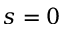<formula> <loc_0><loc_0><loc_500><loc_500>s = 0</formula> 